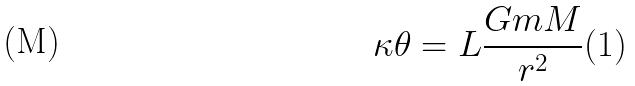<formula> <loc_0><loc_0><loc_500><loc_500>\kappa \theta = L \frac { G m M } { r ^ { 2 } } ( 1 )</formula> 